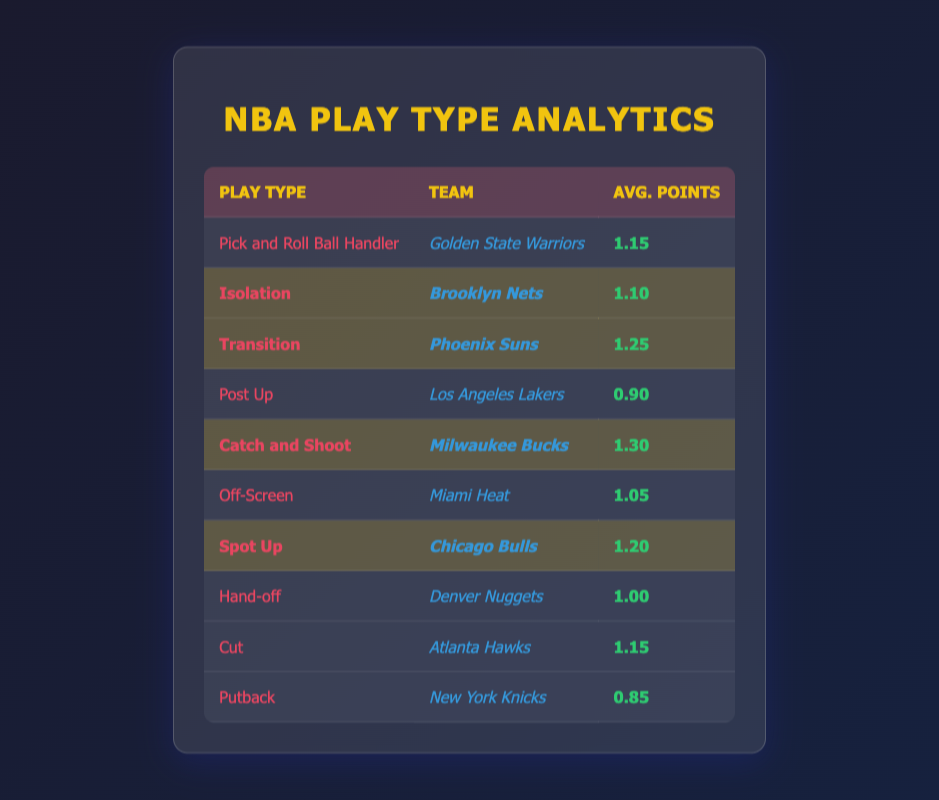What play type has the highest average points per possession this season? The table shows the average points per possession for various play types. The highest value is 1.30, which is for the "Catch and Shoot" play type by the Milwaukee Bucks.
Answer: Catch and Shoot Which team is associated with the Transition play type? The Transition play type is associated with the Phoenix Suns, which has an average of 1.25 points per possession as indicated in the table.
Answer: Phoenix Suns Is the average points per possession for Isolation higher than that for Post Up? The average points for Isolation is 1.10, while for Post Up it is 0.90. Since 1.10 is greater than 0.90, the statement is true.
Answer: Yes What is the difference in average points per possession between Catch and Shoot and Isolation? The average for Catch and Shoot is 1.30 and for Isolation is 1.10. The difference is calculated as 1.30 - 1.10 = 0.20.
Answer: 0.20 Which play type has an average points per possession below 1.00? The table shows that the "Post Up" with 0.90 and "Putback" with 0.85 are below 1.00.
Answer: Post Up, Putback How many play types have an average points greater than 1.15? By examining the table, there are four play types: Transition (1.25), Catch and Shoot (1.30), Spot Up (1.20), and "Pick and Roll Ball Handler" with the same value of 1.15 or higher. Thus, there are five play types total.
Answer: 4 Which team ranks highest in the average points for Spot Up? The Spot Up play type is associated with the Chicago Bulls, which has an average of 1.20 points per possession according to the table.
Answer: Chicago Bulls If we average the points of all highlighted play types, what do we get? The highlighted play types’ averages are: Isolation (1.10), Transition (1.25), Catch and Shoot (1.30), and Spot Up (1.20). Summing these values gives 1.10 + 1.25 + 1.30 + 1.20 = 4.85. Dividing by 4 gives an average of 4.85 / 4 = 1.2125.
Answer: 1.21 What percentage of the play types listed have an average points per possession of 1.10 or above? There are 10 play types in total. The ones that are 1.10 or above are Pick and Roll Ball Handler (1.15), Isolation (1.10), Transition (1.25), Catch and Shoot (1.30), Spot Up (1.20), and Cut (1.15). This totals 6 play types, which means the percentage is (6/10) * 100 = 60%.
Answer: 60% 